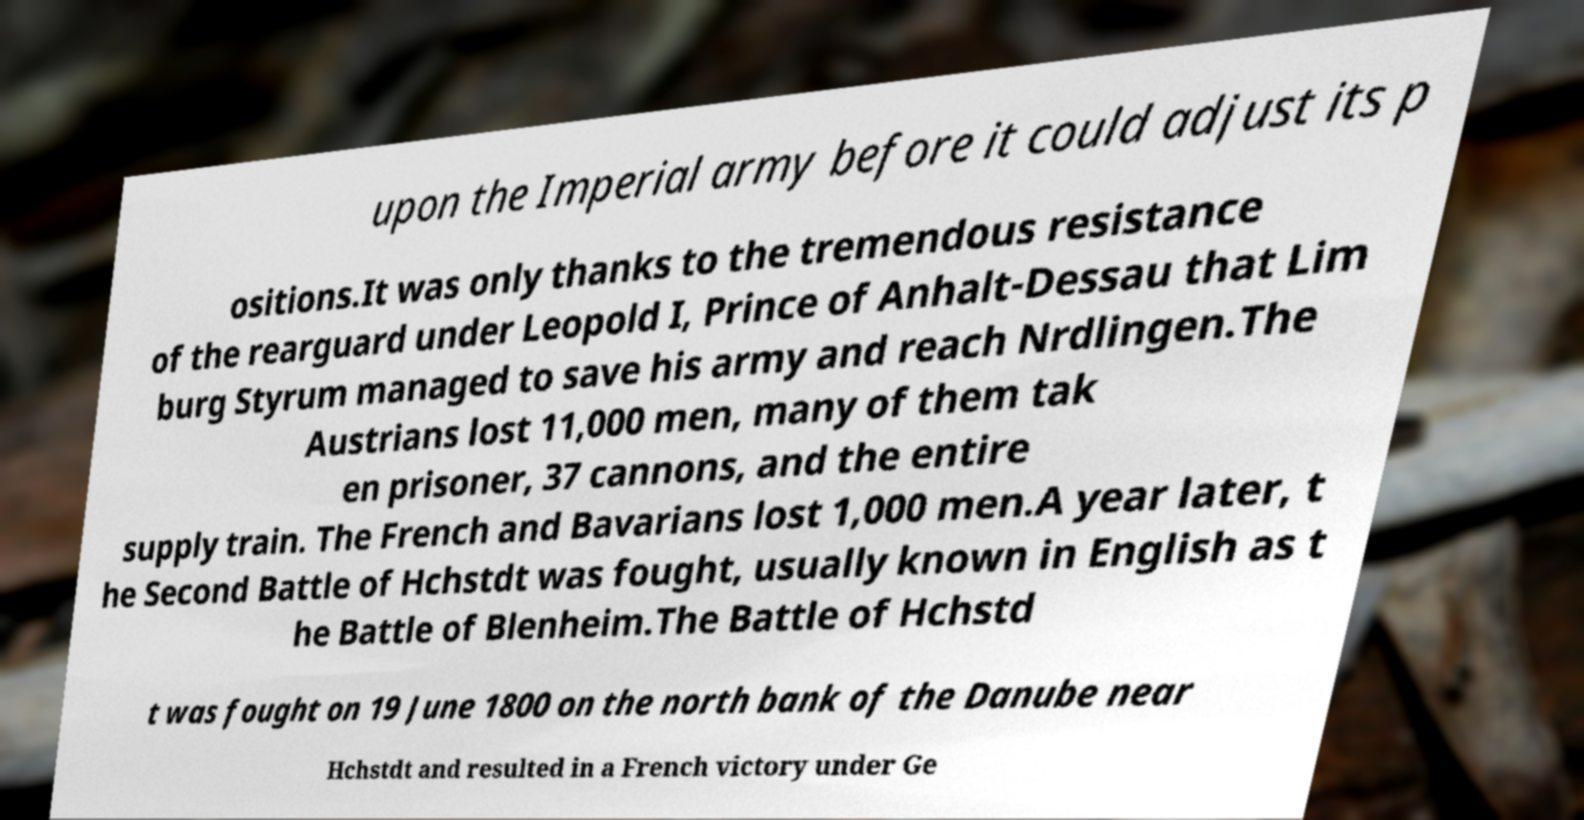For documentation purposes, I need the text within this image transcribed. Could you provide that? upon the Imperial army before it could adjust its p ositions.It was only thanks to the tremendous resistance of the rearguard under Leopold I, Prince of Anhalt-Dessau that Lim burg Styrum managed to save his army and reach Nrdlingen.The Austrians lost 11,000 men, many of them tak en prisoner, 37 cannons, and the entire supply train. The French and Bavarians lost 1,000 men.A year later, t he Second Battle of Hchstdt was fought, usually known in English as t he Battle of Blenheim.The Battle of Hchstd t was fought on 19 June 1800 on the north bank of the Danube near Hchstdt and resulted in a French victory under Ge 